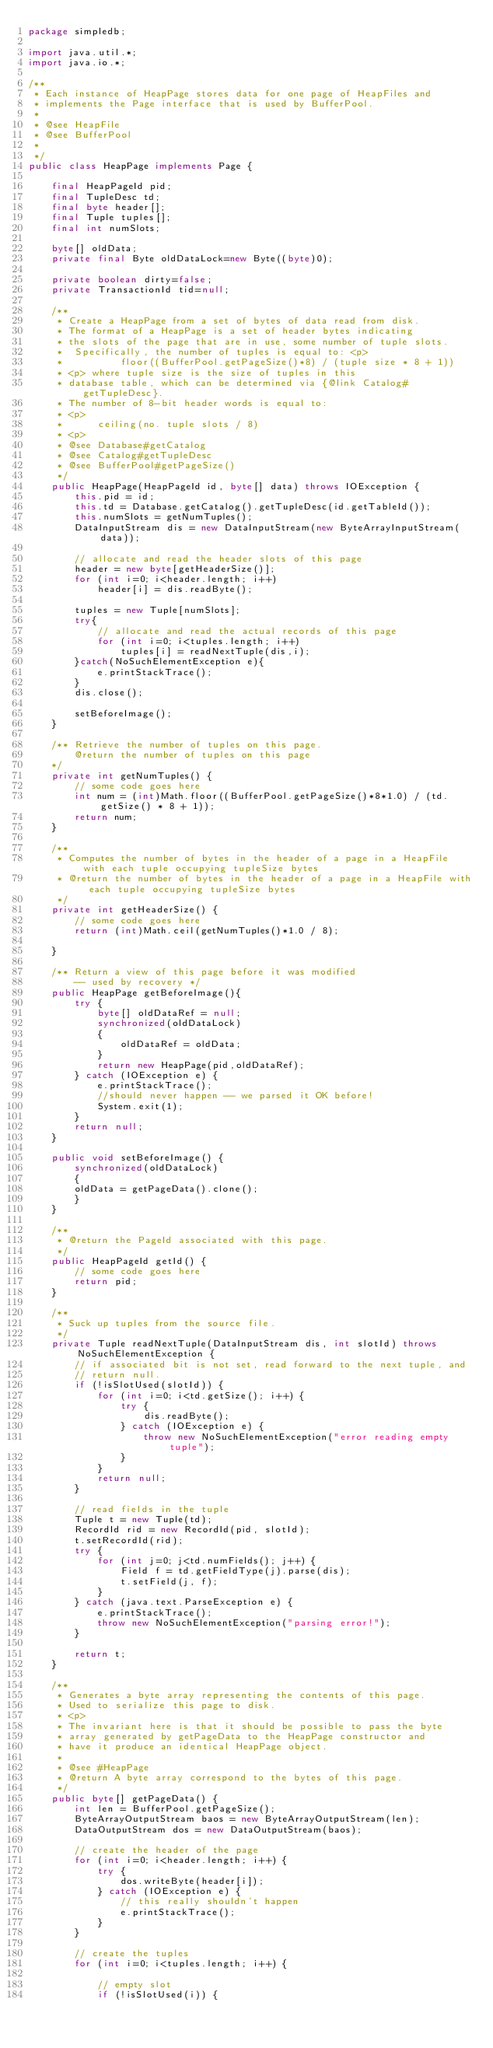Convert code to text. <code><loc_0><loc_0><loc_500><loc_500><_Java_>package simpledb;

import java.util.*;
import java.io.*;

/**
 * Each instance of HeapPage stores data for one page of HeapFiles and 
 * implements the Page interface that is used by BufferPool.
 *
 * @see HeapFile
 * @see BufferPool
 *
 */
public class HeapPage implements Page {

    final HeapPageId pid;
    final TupleDesc td;
    final byte header[];
    final Tuple tuples[];
    final int numSlots;

    byte[] oldData;
    private final Byte oldDataLock=new Byte((byte)0);
    
    private boolean dirty=false;
    private TransactionId tid=null;

    /**
     * Create a HeapPage from a set of bytes of data read from disk.
     * The format of a HeapPage is a set of header bytes indicating
     * the slots of the page that are in use, some number of tuple slots.
     *  Specifically, the number of tuples is equal to: <p>
     *          floor((BufferPool.getPageSize()*8) / (tuple size * 8 + 1))
     * <p> where tuple size is the size of tuples in this
     * database table, which can be determined via {@link Catalog#getTupleDesc}.
     * The number of 8-bit header words is equal to:
     * <p>
     *      ceiling(no. tuple slots / 8)
     * <p>
     * @see Database#getCatalog
     * @see Catalog#getTupleDesc
     * @see BufferPool#getPageSize()
     */
    public HeapPage(HeapPageId id, byte[] data) throws IOException {
        this.pid = id;
        this.td = Database.getCatalog().getTupleDesc(id.getTableId());
        this.numSlots = getNumTuples();
        DataInputStream dis = new DataInputStream(new ByteArrayInputStream(data));

        // allocate and read the header slots of this page
        header = new byte[getHeaderSize()];
        for (int i=0; i<header.length; i++)
            header[i] = dis.readByte();
        
        tuples = new Tuple[numSlots];
        try{
            // allocate and read the actual records of this page
            for (int i=0; i<tuples.length; i++)
                tuples[i] = readNextTuple(dis,i);
        }catch(NoSuchElementException e){
            e.printStackTrace();
        }
        dis.close();

        setBeforeImage();
    }

    /** Retrieve the number of tuples on this page.
        @return the number of tuples on this page
    */
    private int getNumTuples() {        
        // some code goes here
        int num = (int)Math.floor((BufferPool.getPageSize()*8*1.0) / (td.getSize() * 8 + 1));
        return num;
    }

    /**
     * Computes the number of bytes in the header of a page in a HeapFile with each tuple occupying tupleSize bytes
     * @return the number of bytes in the header of a page in a HeapFile with each tuple occupying tupleSize bytes
     */
    private int getHeaderSize() {        
        // some code goes here
        return (int)Math.ceil(getNumTuples()*1.0 / 8);
                 
    }
    
    /** Return a view of this page before it was modified
        -- used by recovery */
    public HeapPage getBeforeImage(){
        try {
            byte[] oldDataRef = null;
            synchronized(oldDataLock)
            {
                oldDataRef = oldData;
            }
            return new HeapPage(pid,oldDataRef);
        } catch (IOException e) {
            e.printStackTrace();
            //should never happen -- we parsed it OK before!
            System.exit(1);
        }
        return null;
    }
    
    public void setBeforeImage() {
        synchronized(oldDataLock)
        {
        oldData = getPageData().clone();
        }
    }

    /**
     * @return the PageId associated with this page.
     */
    public HeapPageId getId() {
        // some code goes here
        return pid;
    }

    /**
     * Suck up tuples from the source file.
     */
    private Tuple readNextTuple(DataInputStream dis, int slotId) throws NoSuchElementException {
        // if associated bit is not set, read forward to the next tuple, and
        // return null.
        if (!isSlotUsed(slotId)) {
            for (int i=0; i<td.getSize(); i++) {
                try {
                    dis.readByte();
                } catch (IOException e) {
                    throw new NoSuchElementException("error reading empty tuple");
                }
            }
            return null;
        }

        // read fields in the tuple
        Tuple t = new Tuple(td);
        RecordId rid = new RecordId(pid, slotId);
        t.setRecordId(rid);
        try {
            for (int j=0; j<td.numFields(); j++) {
                Field f = td.getFieldType(j).parse(dis);
                t.setField(j, f);
            }
        } catch (java.text.ParseException e) {
            e.printStackTrace();
            throw new NoSuchElementException("parsing error!");
        }

        return t;
    }

    /**
     * Generates a byte array representing the contents of this page.
     * Used to serialize this page to disk.
     * <p>
     * The invariant here is that it should be possible to pass the byte
     * array generated by getPageData to the HeapPage constructor and
     * have it produce an identical HeapPage object.
     *
     * @see #HeapPage
     * @return A byte array correspond to the bytes of this page.
     */
    public byte[] getPageData() {
        int len = BufferPool.getPageSize();
        ByteArrayOutputStream baos = new ByteArrayOutputStream(len);
        DataOutputStream dos = new DataOutputStream(baos);

        // create the header of the page
        for (int i=0; i<header.length; i++) {
            try {
                dos.writeByte(header[i]);
            } catch (IOException e) {
                // this really shouldn't happen
                e.printStackTrace();
            }
        }

        // create the tuples
        for (int i=0; i<tuples.length; i++) {

            // empty slot
            if (!isSlotUsed(i)) {</code> 